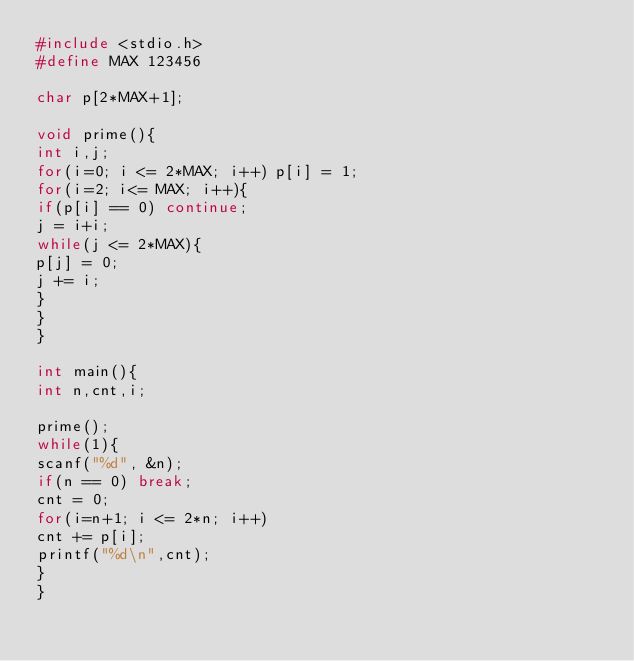<code> <loc_0><loc_0><loc_500><loc_500><_C_>#include <stdio.h>
#define MAX 123456

char p[2*MAX+1];

void prime(){
int i,j;
for(i=0; i <= 2*MAX; i++) p[i] = 1;
for(i=2; i<= MAX; i++){
if(p[i] == 0) continue;
j = i+i;
while(j <= 2*MAX){
p[j] = 0;
j += i;
}
}
}

int main(){
int n,cnt,i;

prime();
while(1){
scanf("%d", &n);
if(n == 0) break;
cnt = 0;
for(i=n+1; i <= 2*n; i++)
cnt += p[i];
printf("%d\n",cnt);
}
}</code> 